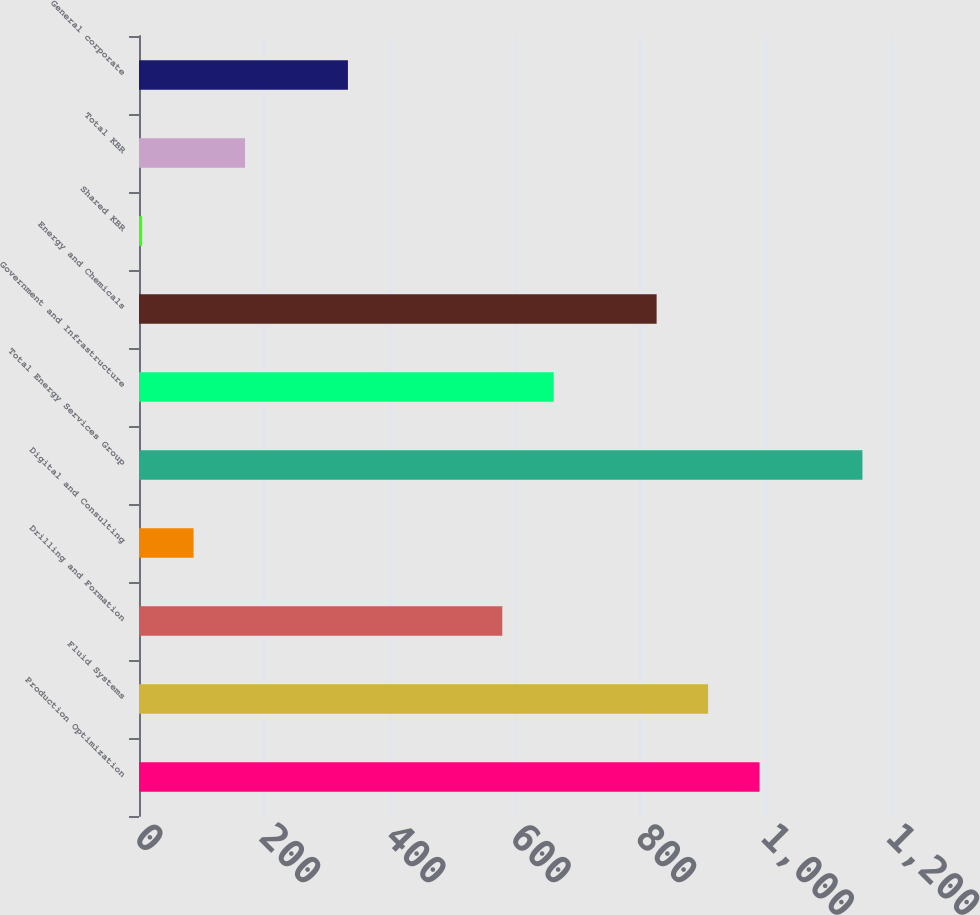Convert chart. <chart><loc_0><loc_0><loc_500><loc_500><bar_chart><fcel>Production Optimization<fcel>Fluid Systems<fcel>Drilling and Formation<fcel>Digital and Consulting<fcel>Total Energy Services Group<fcel>Government and Infrastructure<fcel>Energy and Chemicals<fcel>Shared KBR<fcel>Total KBR<fcel>General corporate<nl><fcel>990.2<fcel>908.1<fcel>579.7<fcel>87.1<fcel>1154.4<fcel>661.8<fcel>826<fcel>5<fcel>169.2<fcel>333.4<nl></chart> 